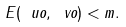Convert formula to latex. <formula><loc_0><loc_0><loc_500><loc_500>E ( \ u o , \ v o ) < m .</formula> 